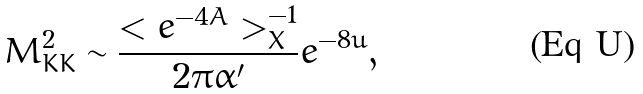<formula> <loc_0><loc_0><loc_500><loc_500>M _ { K K } ^ { 2 } \sim \frac { < e ^ { - 4 A } > _ { X } ^ { - 1 } } { 2 \pi \alpha ^ { \prime } } e ^ { - 8 u } ,</formula> 